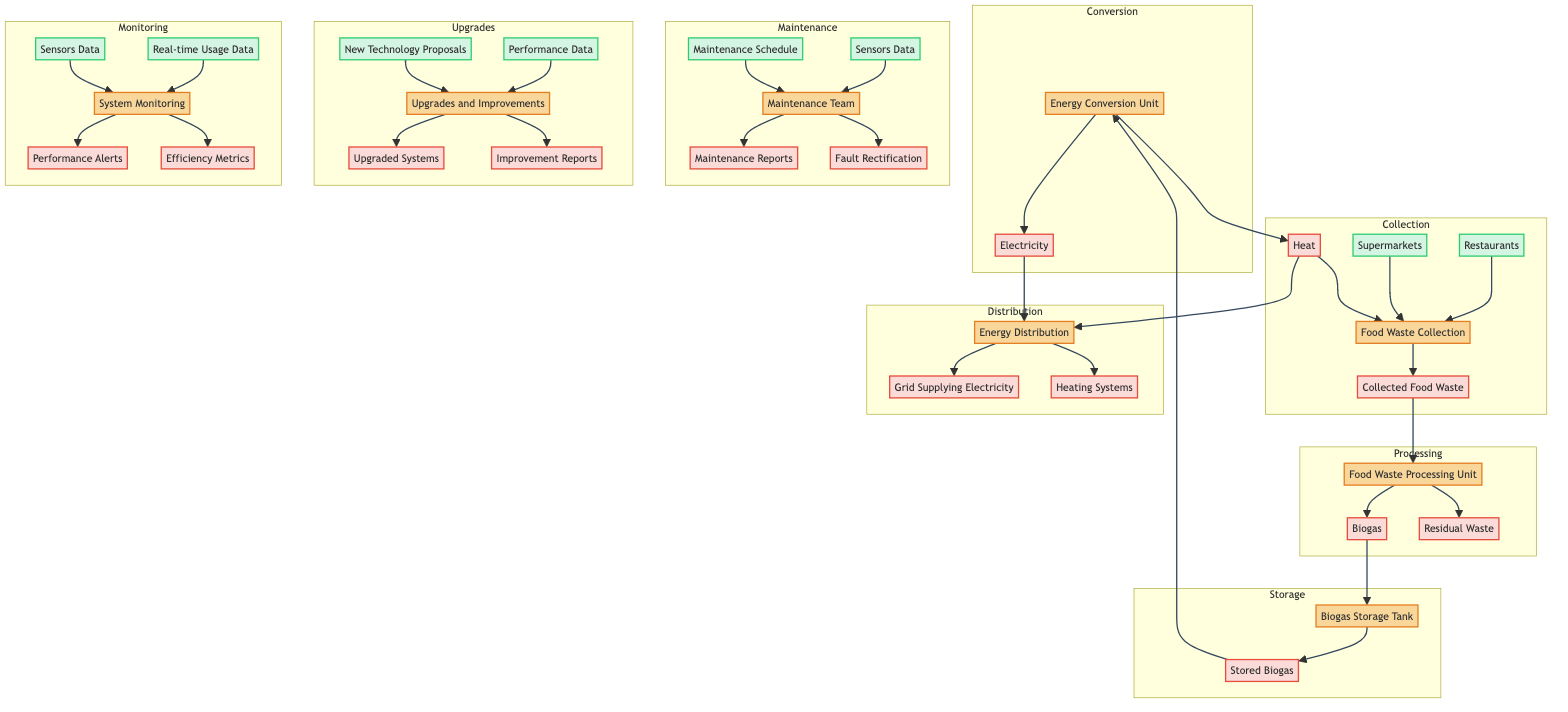What are the sources for food waste collection? The diagram lists three sources for food waste collection: Restaurants, Supermarkets, and Households. These sources are represented as inputs to the Food Waste Collection entity.
Answer: Restaurants, Supermarkets, Households What does the Food Waste Processing Unit output? The Food Waste Processing Unit outputs two items: Biogas and Residual Waste. These outputs are shown directly leading out of the processing unit.
Answer: Biogas, Residual Waste How many output products does the Energy Distribution node manage? The Energy Distribution node manages two output products: Grid Supplying Electricity and Heating Systems. The diagram shows these as the outputs flowing from the Energy Distribution entity.
Answer: 2 What input does the Maintenance Team require for faults rectification? The Maintenance Team requires input from the Maintenance Schedule and Sensors Data for carrying out their process, which is fault rectification, as illustrated in the diagram.
Answer: Maintenance Schedule, Sensors Data If biogas is stored, what are the outputs from the Energy Conversion Unit? After biogas is stored in the Biogas Storage Tank, the Energy Conversion Unit processes this input to generate two outputs: Electricity and Heat, as indicated in the diagram.
Answer: Electricity, Heat What maintains the system's performance monitoring? The system performance monitoring relies on Sensors Data and Real-time Usage Data as inputs to the System Monitoring entity. This monitoring process produces Performance Alerts and Efficiency Metrics as outputs.
Answer: Sensors Data, Real-time Usage Data Which team implements upgrades and improvements? The Upgrades and Improvements entity is responsible for implementing upgrades to enhance efficiency. This is shown in the diagram as a separate entity that receives inputs and generates outputs related to system upgrades.
Answer: Upgrades and Improvements What flows to the Biogas Storage Tank? The Biogas Storage Tank receives input from the output of the Food Waste Processing Unit, specifically Biogas. This relationship is illustrated in the flow between these two entities.
Answer: Biogas How is collected food waste obtained? Collected Food Waste is obtained from the Food Waste Collection process, which combines the inputs from Restaurants, Supermarkets, and Households. This relationship is shown in the diagram as the starting point of the flow.
Answer: Collected Food Waste 